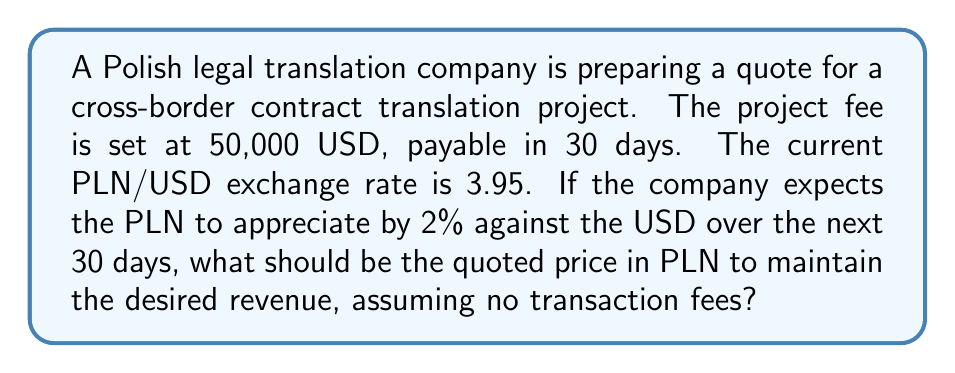Can you answer this question? To solve this problem, we need to follow these steps:

1. Calculate the expected exchange rate after 30 days:
   Current rate: $3.95 \text{ PLN/USD}$
   Expected appreciation: $2\% = 0.02$
   
   New rate = $3.95 \times (1 - 0.02) = 3.95 \times 0.98 = 3.871 \text{ PLN/USD}$

2. Calculate the PLN equivalent of 50,000 USD at the expected future rate:
   $50,000 \text{ USD} \times 3.871 \text{ PLN/USD} = 193,550 \text{ PLN}$

3. To maintain the desired revenue, we need to quote a price that, when converted at the current rate, equals 50,000 USD:

   Let $x$ be the quoted price in PLN.
   
   $$\frac{x \text{ PLN}}{3.95 \text{ PLN/USD}} = 50,000 \text{ USD}$$

   Solving for $x$:
   
   $$x = 50,000 \times 3.95 = 197,500 \text{ PLN}$$

Therefore, the company should quote 197,500 PLN to maintain the desired revenue of 50,000 USD, accounting for the expected currency fluctuation.
Answer: 197,500 PLN 